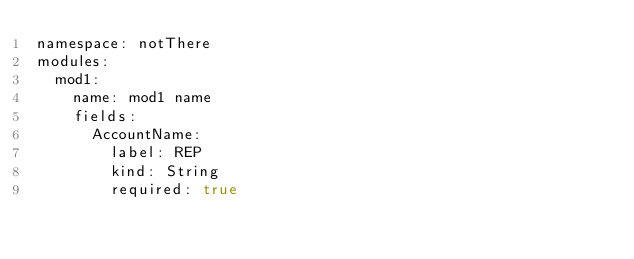<code> <loc_0><loc_0><loc_500><loc_500><_YAML_>namespace: notThere
modules:
  mod1:
    name: mod1 name
    fields:
      AccountName:
        label: REP
        kind: String
        required: true
</code> 